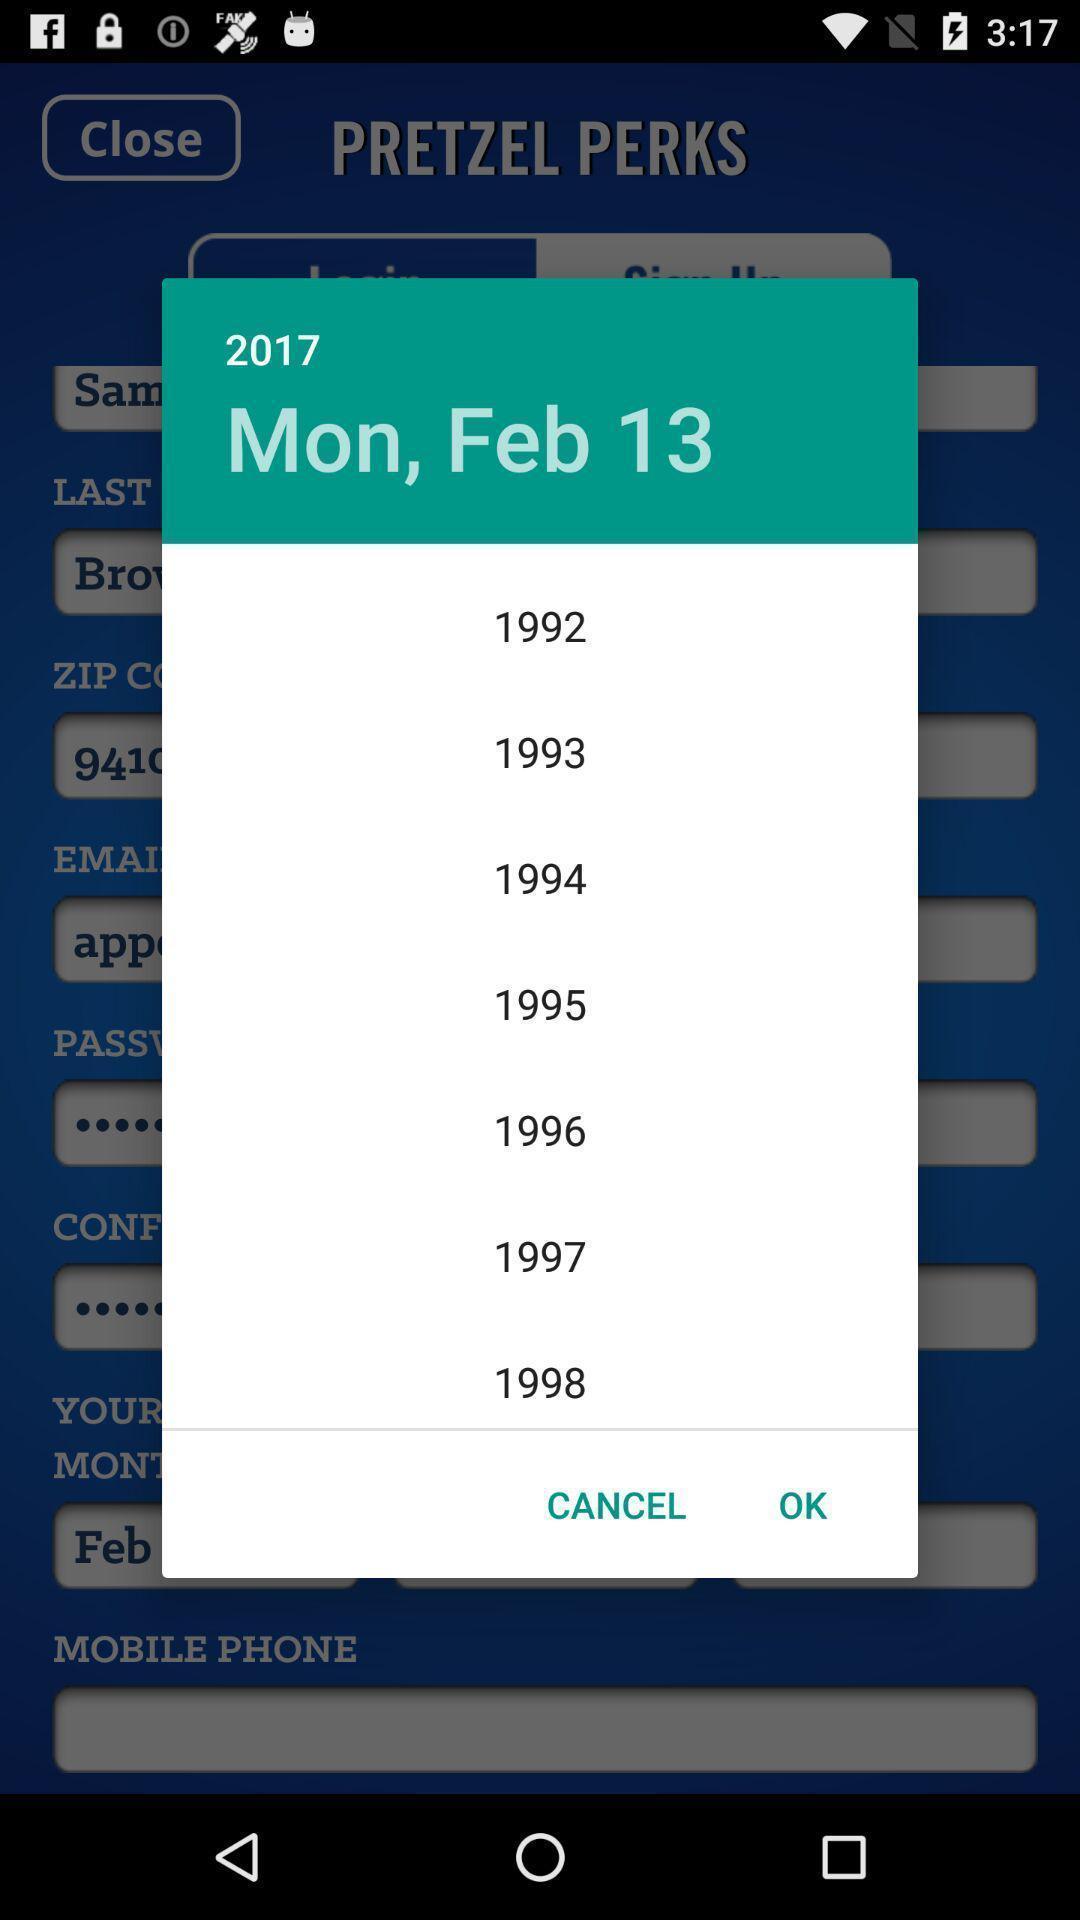What is the overall content of this screenshot? Pop-up showing the date in a calender. 